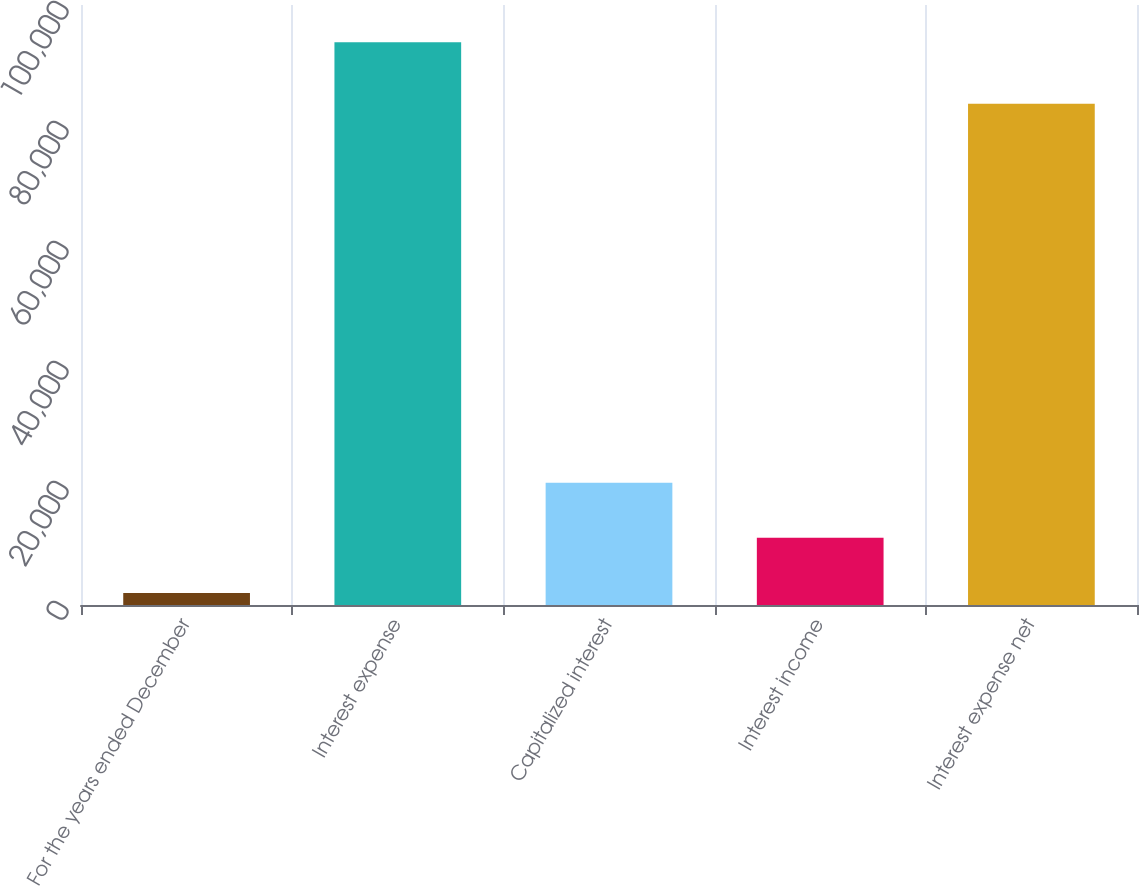<chart> <loc_0><loc_0><loc_500><loc_500><bar_chart><fcel>For the years ended December<fcel>Interest expense<fcel>Capitalized interest<fcel>Interest income<fcel>Interest expense net<nl><fcel>2014<fcel>93777<fcel>20366.6<fcel>11190.3<fcel>83532<nl></chart> 